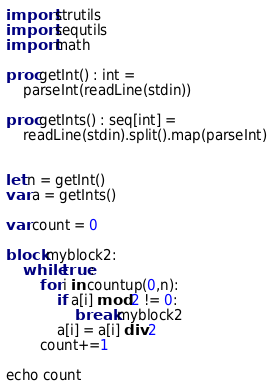<code> <loc_0><loc_0><loc_500><loc_500><_Nim_>import strutils
import sequtils
import math 

proc getInt() : int =
    parseInt(readLine(stdin))

proc getInts() : seq[int] = 
    readLine(stdin).split().map(parseInt)


let n = getInt()
var a = getInts()

var count = 0

block myblock2:
    while true:
        for i in countup(0,n):
            if a[i] mod 2 != 0:
                break myblock2
            a[i] = a[i] div 2
        count+=1
    
echo count

</code> 